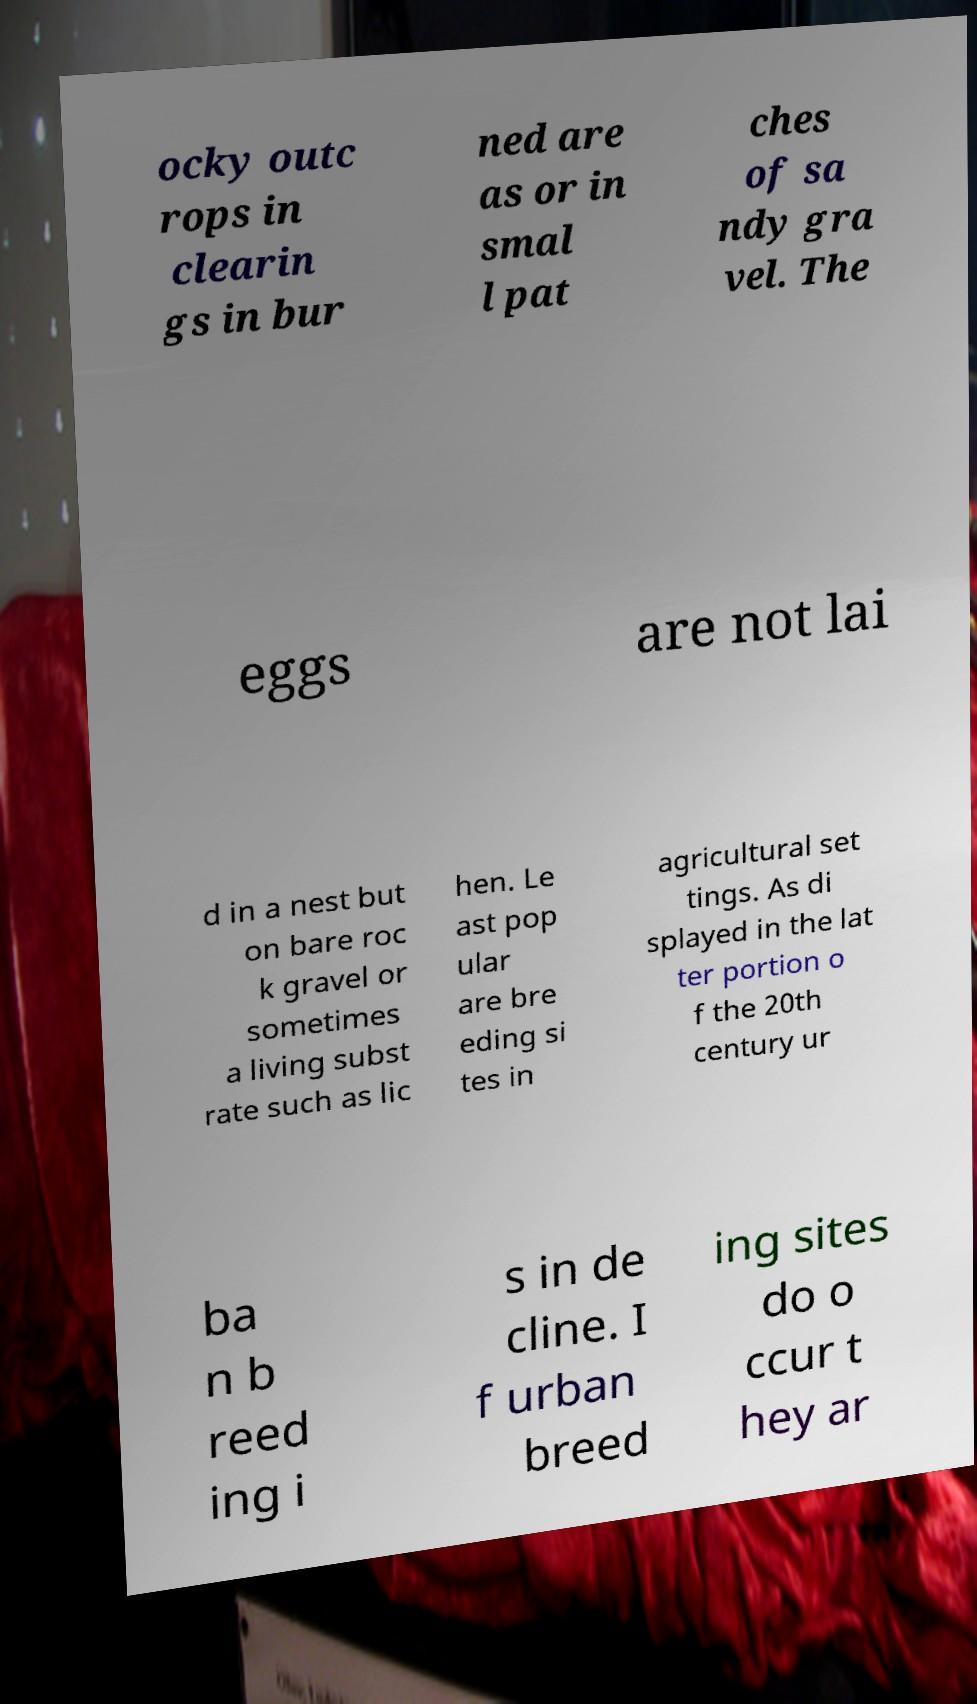Please read and relay the text visible in this image. What does it say? ocky outc rops in clearin gs in bur ned are as or in smal l pat ches of sa ndy gra vel. The eggs are not lai d in a nest but on bare roc k gravel or sometimes a living subst rate such as lic hen. Le ast pop ular are bre eding si tes in agricultural set tings. As di splayed in the lat ter portion o f the 20th century ur ba n b reed ing i s in de cline. I f urban breed ing sites do o ccur t hey ar 